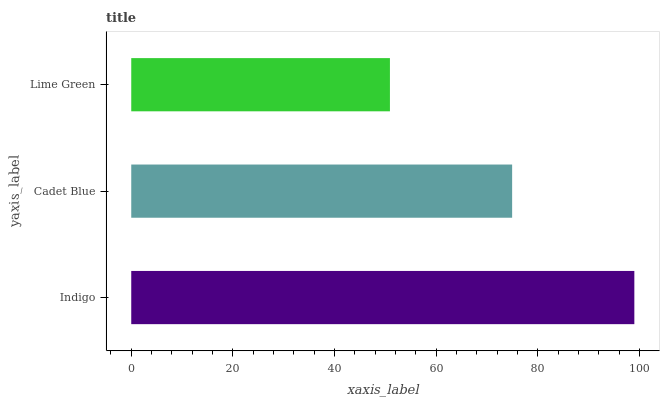Is Lime Green the minimum?
Answer yes or no. Yes. Is Indigo the maximum?
Answer yes or no. Yes. Is Cadet Blue the minimum?
Answer yes or no. No. Is Cadet Blue the maximum?
Answer yes or no. No. Is Indigo greater than Cadet Blue?
Answer yes or no. Yes. Is Cadet Blue less than Indigo?
Answer yes or no. Yes. Is Cadet Blue greater than Indigo?
Answer yes or no. No. Is Indigo less than Cadet Blue?
Answer yes or no. No. Is Cadet Blue the high median?
Answer yes or no. Yes. Is Cadet Blue the low median?
Answer yes or no. Yes. Is Lime Green the high median?
Answer yes or no. No. Is Lime Green the low median?
Answer yes or no. No. 